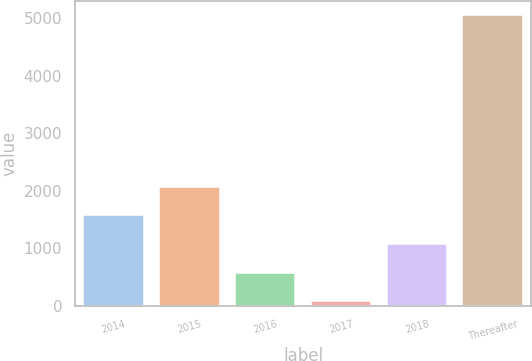<chart> <loc_0><loc_0><loc_500><loc_500><bar_chart><fcel>2014<fcel>2015<fcel>2016<fcel>2017<fcel>2018<fcel>Thereafter<nl><fcel>1570.42<fcel>2067.86<fcel>575.54<fcel>78.1<fcel>1072.98<fcel>5052.5<nl></chart> 